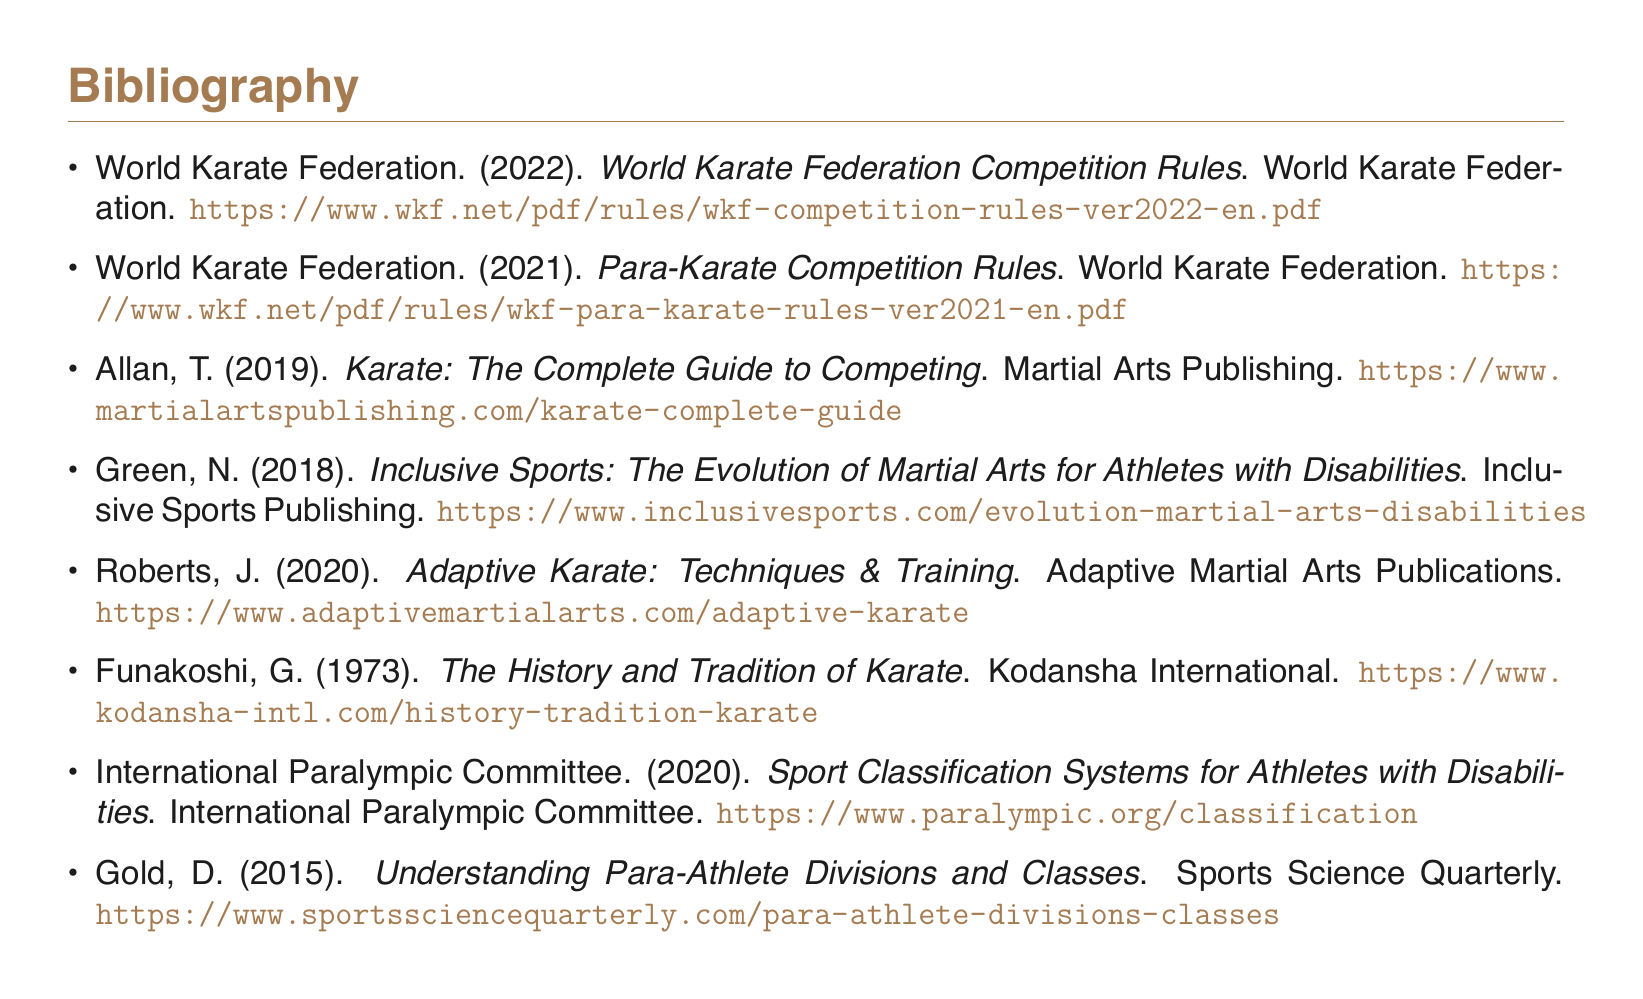What is the title of the document? The title of the document is usually mentioned in the introduction or cover page. In this case, it is referred to in the provided data as "Bibliography".
Answer: Bibliography How many items are listed in the bibliography? The total number of items can be counted directly from the list presented in the document. Here, there are eight items.
Answer: 8 Who published the "World Karate Federation Competition Rules"? The publisher of this specific rule set is indicated in the item description. The publisher is the "World Karate Federation".
Answer: World Karate Federation What year was the "Adaptive Karate: Techniques & Training" published? The year of publication is given in the bibliographic entry for that specific item. It was published in 2020.
Answer: 2020 What is the focus of the book by Green, N.? The specific area of focus is derived from the title of the book provided in the bibliography. It discusses the evolution of martial arts for athletes with disabilities.
Answer: Evolution of Martial Arts for Athletes with Disabilities What organization produced the "Sport Classification Systems for Athletes with Disabilities"? This can be found in the bibliographic entry which names the organization as the "International Paralympic Committee".
Answer: International Paralympic Committee What is the URL for the "Para-Karate Competition Rules"? The URL can be directly extracted from the bibliographic entry corresponding to this item.
Answer: https://www.wkf.net/pdf/rules/wkf-para-karate-rules-ver2021-en.pdf Which publication discusses "Understanding Para-Athlete Divisions and Classes"? The specific title is mentioned in the bibliography, indicating its relevance to the topic at hand. The author is Gold, D.
Answer: Gold, D 